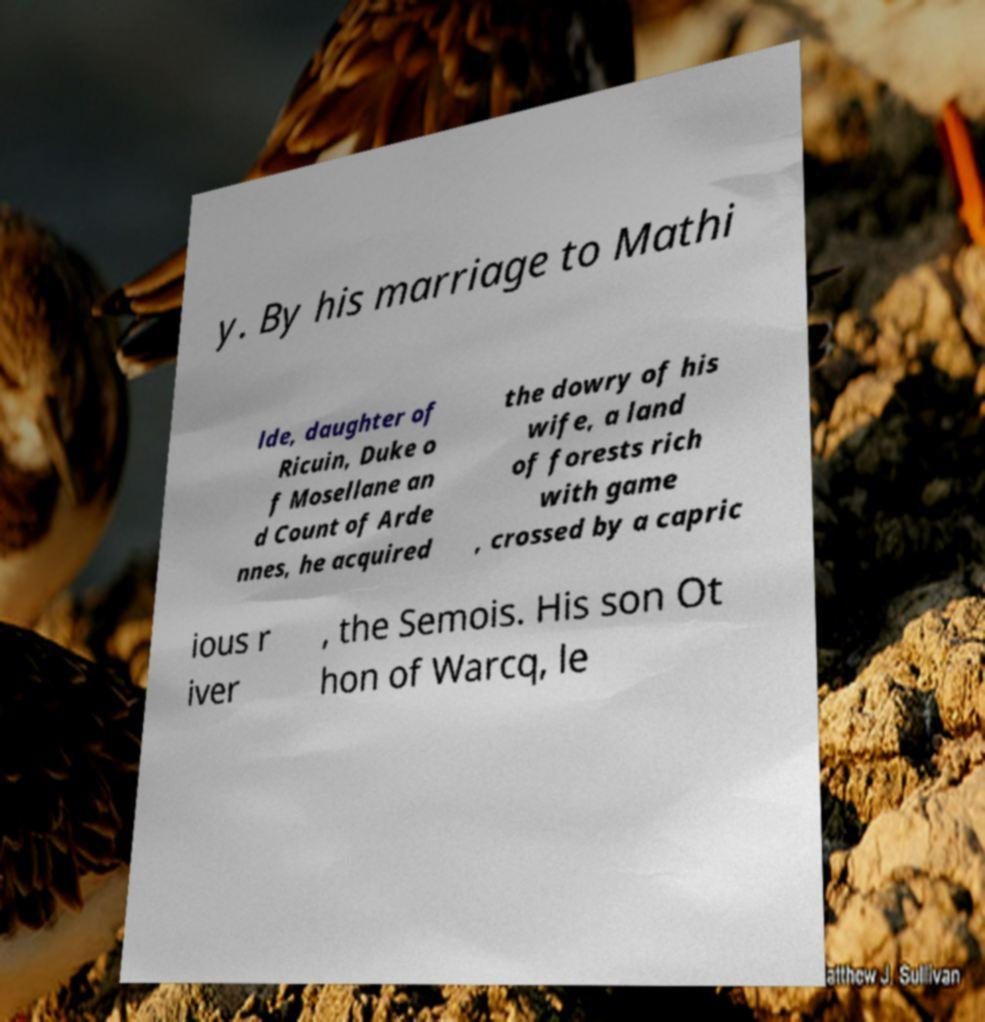Please read and relay the text visible in this image. What does it say? y. By his marriage to Mathi lde, daughter of Ricuin, Duke o f Mosellane an d Count of Arde nnes, he acquired the dowry of his wife, a land of forests rich with game , crossed by a capric ious r iver , the Semois. His son Ot hon of Warcq, le 